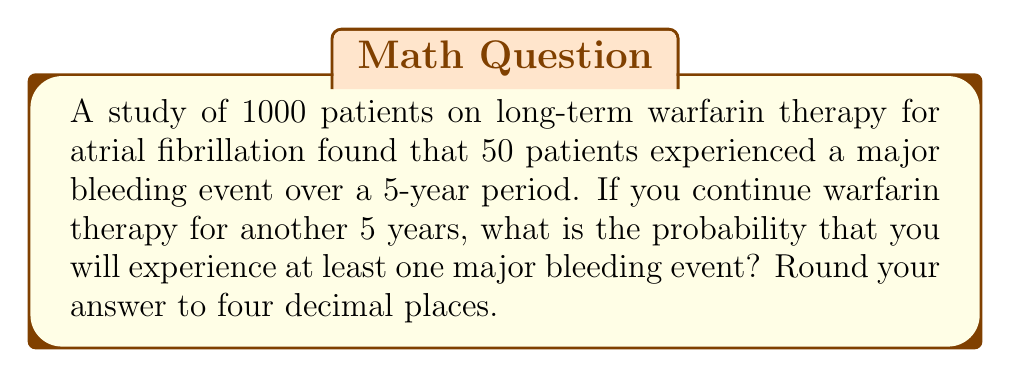Help me with this question. Let's approach this step-by-step:

1) First, we need to calculate the probability of experiencing a major bleeding event in a 5-year period:

   $P(\text{bleeding event in 5 years}) = \frac{50}{1000} = 0.05$ or 5%

2) Now, we want to find the probability of experiencing at least one bleeding event in 10 years (two 5-year periods).

3) It's easier to calculate the probability of not experiencing any bleeding events in 10 years and then subtract this from 1.

4) The probability of not experiencing a bleeding event in 5 years is:

   $P(\text{no bleeding in 5 years}) = 1 - 0.05 = 0.95$ or 95%

5) For no bleeding events to occur in 10 years, we need to avoid bleeding in both 5-year periods. Assuming the periods are independent:

   $P(\text{no bleeding in 10 years}) = 0.95 \times 0.95 = 0.9025$

6) Therefore, the probability of experiencing at least one bleeding event in 10 years is:

   $P(\text{at least one bleeding event in 10 years}) = 1 - 0.9025 = 0.0975$

7) Rounding to four decimal places:

   $0.0975 \approx 0.0975$
Answer: 0.0975 